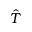<formula> <loc_0><loc_0><loc_500><loc_500>\hat { T }</formula> 